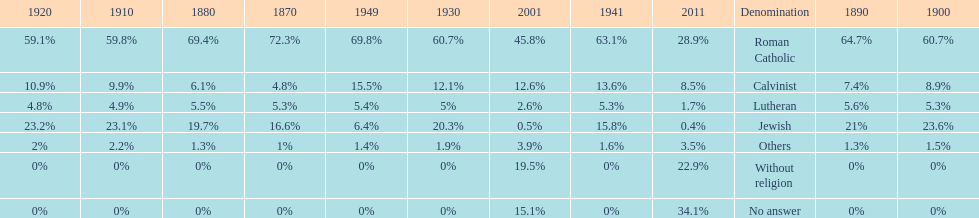The percentage of people who identified as calvinist was, at most, how much? 15.5%. 